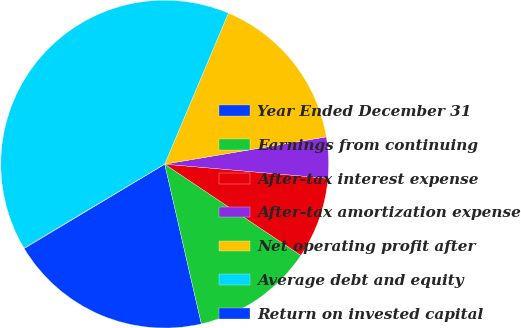Convert chart to OTSL. <chart><loc_0><loc_0><loc_500><loc_500><pie_chart><fcel>Year Ended December 31<fcel>Earnings from continuing<fcel>After-tax interest expense<fcel>After-tax amortization expense<fcel>Net operating profit after<fcel>Average debt and equity<fcel>Return on invested capital<nl><fcel>19.98%<fcel>12.01%<fcel>8.02%<fcel>4.04%<fcel>15.99%<fcel>39.9%<fcel>0.05%<nl></chart> 